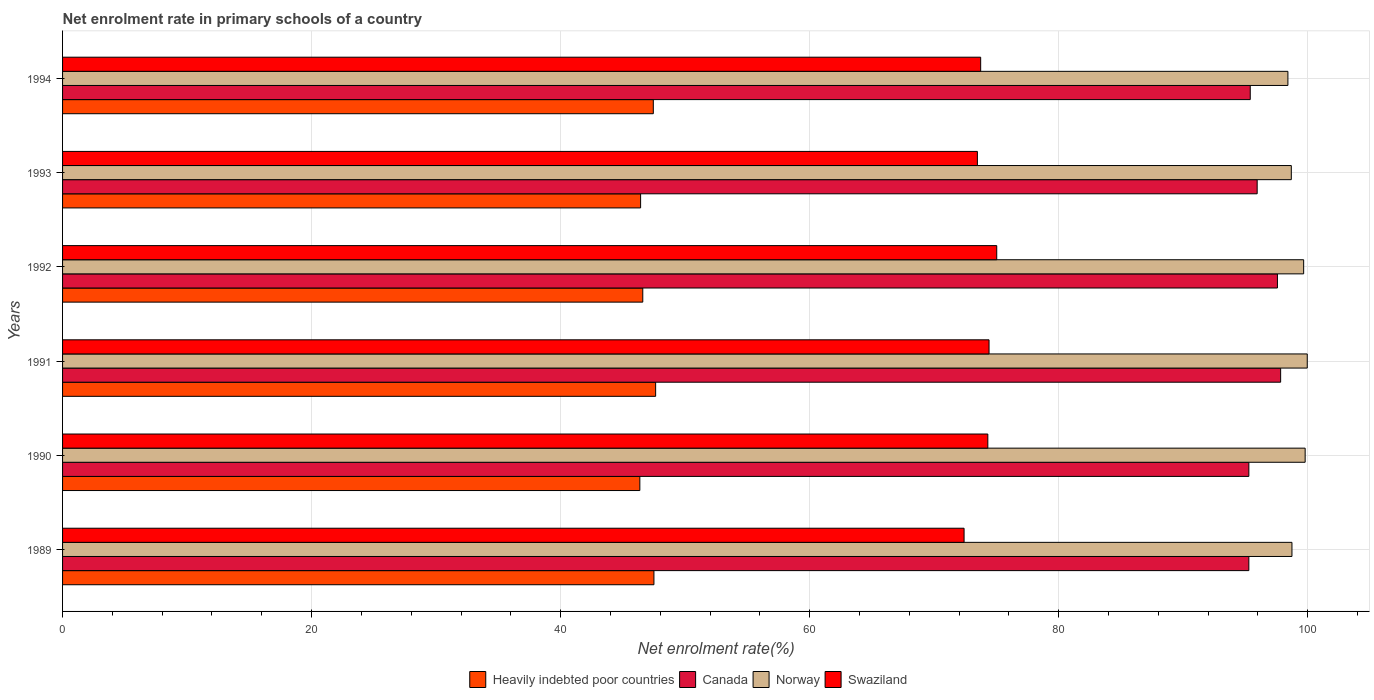How many bars are there on the 2nd tick from the bottom?
Your response must be concise. 4. What is the label of the 6th group of bars from the top?
Your answer should be very brief. 1989. What is the net enrolment rate in primary schools in Canada in 1992?
Provide a short and direct response. 97.57. Across all years, what is the maximum net enrolment rate in primary schools in Norway?
Offer a terse response. 99.97. Across all years, what is the minimum net enrolment rate in primary schools in Norway?
Offer a terse response. 98.41. What is the total net enrolment rate in primary schools in Swaziland in the graph?
Make the answer very short. 443.36. What is the difference between the net enrolment rate in primary schools in Canada in 1989 and that in 1991?
Ensure brevity in your answer.  -2.55. What is the difference between the net enrolment rate in primary schools in Canada in 1990 and the net enrolment rate in primary schools in Norway in 1989?
Make the answer very short. -3.46. What is the average net enrolment rate in primary schools in Canada per year?
Provide a short and direct response. 96.21. In the year 1990, what is the difference between the net enrolment rate in primary schools in Norway and net enrolment rate in primary schools in Canada?
Your response must be concise. 4.52. What is the ratio of the net enrolment rate in primary schools in Norway in 1989 to that in 1994?
Your answer should be very brief. 1. Is the difference between the net enrolment rate in primary schools in Norway in 1989 and 1992 greater than the difference between the net enrolment rate in primary schools in Canada in 1989 and 1992?
Provide a succinct answer. Yes. What is the difference between the highest and the second highest net enrolment rate in primary schools in Heavily indebted poor countries?
Offer a terse response. 0.14. What is the difference between the highest and the lowest net enrolment rate in primary schools in Heavily indebted poor countries?
Offer a very short reply. 1.27. In how many years, is the net enrolment rate in primary schools in Norway greater than the average net enrolment rate in primary schools in Norway taken over all years?
Provide a short and direct response. 3. What does the 4th bar from the top in 1992 represents?
Ensure brevity in your answer.  Heavily indebted poor countries. How many bars are there?
Give a very brief answer. 24. Are all the bars in the graph horizontal?
Provide a succinct answer. Yes. What is the difference between two consecutive major ticks on the X-axis?
Your response must be concise. 20. Are the values on the major ticks of X-axis written in scientific E-notation?
Offer a very short reply. No. Does the graph contain any zero values?
Your response must be concise. No. Where does the legend appear in the graph?
Provide a succinct answer. Bottom center. How many legend labels are there?
Your response must be concise. 4. What is the title of the graph?
Ensure brevity in your answer.  Net enrolment rate in primary schools of a country. What is the label or title of the X-axis?
Give a very brief answer. Net enrolment rate(%). What is the Net enrolment rate(%) in Heavily indebted poor countries in 1989?
Provide a short and direct response. 47.5. What is the Net enrolment rate(%) of Canada in 1989?
Provide a succinct answer. 95.27. What is the Net enrolment rate(%) of Norway in 1989?
Make the answer very short. 98.74. What is the Net enrolment rate(%) of Swaziland in 1989?
Give a very brief answer. 72.4. What is the Net enrolment rate(%) in Heavily indebted poor countries in 1990?
Make the answer very short. 46.36. What is the Net enrolment rate(%) in Canada in 1990?
Your response must be concise. 95.28. What is the Net enrolment rate(%) of Norway in 1990?
Give a very brief answer. 99.8. What is the Net enrolment rate(%) of Swaziland in 1990?
Provide a succinct answer. 74.31. What is the Net enrolment rate(%) in Heavily indebted poor countries in 1991?
Provide a short and direct response. 47.63. What is the Net enrolment rate(%) in Canada in 1991?
Keep it short and to the point. 97.83. What is the Net enrolment rate(%) of Norway in 1991?
Make the answer very short. 99.97. What is the Net enrolment rate(%) in Swaziland in 1991?
Your answer should be compact. 74.41. What is the Net enrolment rate(%) of Heavily indebted poor countries in 1992?
Offer a terse response. 46.6. What is the Net enrolment rate(%) in Canada in 1992?
Your answer should be very brief. 97.57. What is the Net enrolment rate(%) of Norway in 1992?
Give a very brief answer. 99.68. What is the Net enrolment rate(%) of Swaziland in 1992?
Keep it short and to the point. 75.03. What is the Net enrolment rate(%) in Heavily indebted poor countries in 1993?
Your response must be concise. 46.43. What is the Net enrolment rate(%) of Canada in 1993?
Offer a terse response. 95.94. What is the Net enrolment rate(%) of Norway in 1993?
Your answer should be compact. 98.69. What is the Net enrolment rate(%) in Swaziland in 1993?
Ensure brevity in your answer.  73.47. What is the Net enrolment rate(%) of Heavily indebted poor countries in 1994?
Ensure brevity in your answer.  47.45. What is the Net enrolment rate(%) of Canada in 1994?
Your answer should be compact. 95.39. What is the Net enrolment rate(%) of Norway in 1994?
Provide a short and direct response. 98.41. What is the Net enrolment rate(%) of Swaziland in 1994?
Ensure brevity in your answer.  73.74. Across all years, what is the maximum Net enrolment rate(%) of Heavily indebted poor countries?
Give a very brief answer. 47.63. Across all years, what is the maximum Net enrolment rate(%) of Canada?
Your answer should be compact. 97.83. Across all years, what is the maximum Net enrolment rate(%) of Norway?
Your answer should be very brief. 99.97. Across all years, what is the maximum Net enrolment rate(%) of Swaziland?
Provide a short and direct response. 75.03. Across all years, what is the minimum Net enrolment rate(%) of Heavily indebted poor countries?
Provide a short and direct response. 46.36. Across all years, what is the minimum Net enrolment rate(%) in Canada?
Offer a very short reply. 95.27. Across all years, what is the minimum Net enrolment rate(%) of Norway?
Offer a terse response. 98.41. Across all years, what is the minimum Net enrolment rate(%) in Swaziland?
Offer a terse response. 72.4. What is the total Net enrolment rate(%) in Heavily indebted poor countries in the graph?
Your response must be concise. 281.96. What is the total Net enrolment rate(%) in Canada in the graph?
Provide a succinct answer. 577.28. What is the total Net enrolment rate(%) of Norway in the graph?
Keep it short and to the point. 595.28. What is the total Net enrolment rate(%) in Swaziland in the graph?
Offer a very short reply. 443.36. What is the difference between the Net enrolment rate(%) of Heavily indebted poor countries in 1989 and that in 1990?
Give a very brief answer. 1.13. What is the difference between the Net enrolment rate(%) in Canada in 1989 and that in 1990?
Offer a very short reply. -0. What is the difference between the Net enrolment rate(%) of Norway in 1989 and that in 1990?
Your answer should be very brief. -1.06. What is the difference between the Net enrolment rate(%) in Swaziland in 1989 and that in 1990?
Your answer should be compact. -1.91. What is the difference between the Net enrolment rate(%) of Heavily indebted poor countries in 1989 and that in 1991?
Offer a very short reply. -0.14. What is the difference between the Net enrolment rate(%) in Canada in 1989 and that in 1991?
Offer a very short reply. -2.55. What is the difference between the Net enrolment rate(%) in Norway in 1989 and that in 1991?
Your response must be concise. -1.23. What is the difference between the Net enrolment rate(%) of Swaziland in 1989 and that in 1991?
Give a very brief answer. -2.01. What is the difference between the Net enrolment rate(%) of Heavily indebted poor countries in 1989 and that in 1992?
Keep it short and to the point. 0.9. What is the difference between the Net enrolment rate(%) in Canada in 1989 and that in 1992?
Offer a terse response. -2.3. What is the difference between the Net enrolment rate(%) in Norway in 1989 and that in 1992?
Offer a terse response. -0.94. What is the difference between the Net enrolment rate(%) of Swaziland in 1989 and that in 1992?
Your response must be concise. -2.62. What is the difference between the Net enrolment rate(%) of Heavily indebted poor countries in 1989 and that in 1993?
Provide a short and direct response. 1.07. What is the difference between the Net enrolment rate(%) in Canada in 1989 and that in 1993?
Provide a succinct answer. -0.67. What is the difference between the Net enrolment rate(%) of Norway in 1989 and that in 1993?
Offer a very short reply. 0.05. What is the difference between the Net enrolment rate(%) in Swaziland in 1989 and that in 1993?
Provide a short and direct response. -1.07. What is the difference between the Net enrolment rate(%) in Heavily indebted poor countries in 1989 and that in 1994?
Provide a succinct answer. 0.05. What is the difference between the Net enrolment rate(%) of Canada in 1989 and that in 1994?
Your response must be concise. -0.11. What is the difference between the Net enrolment rate(%) of Norway in 1989 and that in 1994?
Give a very brief answer. 0.33. What is the difference between the Net enrolment rate(%) of Swaziland in 1989 and that in 1994?
Your response must be concise. -1.33. What is the difference between the Net enrolment rate(%) of Heavily indebted poor countries in 1990 and that in 1991?
Give a very brief answer. -1.27. What is the difference between the Net enrolment rate(%) in Canada in 1990 and that in 1991?
Offer a terse response. -2.55. What is the difference between the Net enrolment rate(%) of Norway in 1990 and that in 1991?
Make the answer very short. -0.17. What is the difference between the Net enrolment rate(%) of Swaziland in 1990 and that in 1991?
Offer a terse response. -0.1. What is the difference between the Net enrolment rate(%) in Heavily indebted poor countries in 1990 and that in 1992?
Offer a terse response. -0.24. What is the difference between the Net enrolment rate(%) in Canada in 1990 and that in 1992?
Ensure brevity in your answer.  -2.3. What is the difference between the Net enrolment rate(%) in Norway in 1990 and that in 1992?
Keep it short and to the point. 0.12. What is the difference between the Net enrolment rate(%) in Swaziland in 1990 and that in 1992?
Keep it short and to the point. -0.72. What is the difference between the Net enrolment rate(%) in Heavily indebted poor countries in 1990 and that in 1993?
Your answer should be very brief. -0.06. What is the difference between the Net enrolment rate(%) in Canada in 1990 and that in 1993?
Your answer should be compact. -0.67. What is the difference between the Net enrolment rate(%) of Norway in 1990 and that in 1993?
Give a very brief answer. 1.11. What is the difference between the Net enrolment rate(%) in Swaziland in 1990 and that in 1993?
Provide a short and direct response. 0.84. What is the difference between the Net enrolment rate(%) of Heavily indebted poor countries in 1990 and that in 1994?
Provide a short and direct response. -1.08. What is the difference between the Net enrolment rate(%) in Canada in 1990 and that in 1994?
Your answer should be very brief. -0.11. What is the difference between the Net enrolment rate(%) in Norway in 1990 and that in 1994?
Offer a terse response. 1.39. What is the difference between the Net enrolment rate(%) of Swaziland in 1990 and that in 1994?
Offer a terse response. 0.57. What is the difference between the Net enrolment rate(%) of Heavily indebted poor countries in 1991 and that in 1992?
Provide a short and direct response. 1.03. What is the difference between the Net enrolment rate(%) in Canada in 1991 and that in 1992?
Your answer should be very brief. 0.26. What is the difference between the Net enrolment rate(%) of Norway in 1991 and that in 1992?
Give a very brief answer. 0.29. What is the difference between the Net enrolment rate(%) in Swaziland in 1991 and that in 1992?
Ensure brevity in your answer.  -0.62. What is the difference between the Net enrolment rate(%) of Heavily indebted poor countries in 1991 and that in 1993?
Your response must be concise. 1.21. What is the difference between the Net enrolment rate(%) of Canada in 1991 and that in 1993?
Provide a short and direct response. 1.88. What is the difference between the Net enrolment rate(%) in Norway in 1991 and that in 1993?
Offer a very short reply. 1.28. What is the difference between the Net enrolment rate(%) of Swaziland in 1991 and that in 1993?
Make the answer very short. 0.94. What is the difference between the Net enrolment rate(%) of Heavily indebted poor countries in 1991 and that in 1994?
Offer a terse response. 0.19. What is the difference between the Net enrolment rate(%) of Canada in 1991 and that in 1994?
Offer a very short reply. 2.44. What is the difference between the Net enrolment rate(%) in Norway in 1991 and that in 1994?
Offer a very short reply. 1.55. What is the difference between the Net enrolment rate(%) in Swaziland in 1991 and that in 1994?
Offer a very short reply. 0.67. What is the difference between the Net enrolment rate(%) in Heavily indebted poor countries in 1992 and that in 1993?
Your answer should be very brief. 0.17. What is the difference between the Net enrolment rate(%) of Canada in 1992 and that in 1993?
Your answer should be very brief. 1.63. What is the difference between the Net enrolment rate(%) in Norway in 1992 and that in 1993?
Keep it short and to the point. 0.99. What is the difference between the Net enrolment rate(%) of Swaziland in 1992 and that in 1993?
Ensure brevity in your answer.  1.55. What is the difference between the Net enrolment rate(%) of Heavily indebted poor countries in 1992 and that in 1994?
Ensure brevity in your answer.  -0.85. What is the difference between the Net enrolment rate(%) in Canada in 1992 and that in 1994?
Make the answer very short. 2.18. What is the difference between the Net enrolment rate(%) in Norway in 1992 and that in 1994?
Your answer should be very brief. 1.26. What is the difference between the Net enrolment rate(%) of Swaziland in 1992 and that in 1994?
Your answer should be compact. 1.29. What is the difference between the Net enrolment rate(%) in Heavily indebted poor countries in 1993 and that in 1994?
Make the answer very short. -1.02. What is the difference between the Net enrolment rate(%) of Canada in 1993 and that in 1994?
Provide a short and direct response. 0.56. What is the difference between the Net enrolment rate(%) in Norway in 1993 and that in 1994?
Offer a terse response. 0.27. What is the difference between the Net enrolment rate(%) of Swaziland in 1993 and that in 1994?
Offer a very short reply. -0.26. What is the difference between the Net enrolment rate(%) in Heavily indebted poor countries in 1989 and the Net enrolment rate(%) in Canada in 1990?
Ensure brevity in your answer.  -47.78. What is the difference between the Net enrolment rate(%) of Heavily indebted poor countries in 1989 and the Net enrolment rate(%) of Norway in 1990?
Your answer should be very brief. -52.3. What is the difference between the Net enrolment rate(%) in Heavily indebted poor countries in 1989 and the Net enrolment rate(%) in Swaziland in 1990?
Offer a very short reply. -26.82. What is the difference between the Net enrolment rate(%) in Canada in 1989 and the Net enrolment rate(%) in Norway in 1990?
Provide a succinct answer. -4.52. What is the difference between the Net enrolment rate(%) of Canada in 1989 and the Net enrolment rate(%) of Swaziland in 1990?
Your response must be concise. 20.96. What is the difference between the Net enrolment rate(%) of Norway in 1989 and the Net enrolment rate(%) of Swaziland in 1990?
Keep it short and to the point. 24.43. What is the difference between the Net enrolment rate(%) in Heavily indebted poor countries in 1989 and the Net enrolment rate(%) in Canada in 1991?
Make the answer very short. -50.33. What is the difference between the Net enrolment rate(%) of Heavily indebted poor countries in 1989 and the Net enrolment rate(%) of Norway in 1991?
Your response must be concise. -52.47. What is the difference between the Net enrolment rate(%) in Heavily indebted poor countries in 1989 and the Net enrolment rate(%) in Swaziland in 1991?
Offer a terse response. -26.91. What is the difference between the Net enrolment rate(%) in Canada in 1989 and the Net enrolment rate(%) in Norway in 1991?
Provide a short and direct response. -4.69. What is the difference between the Net enrolment rate(%) of Canada in 1989 and the Net enrolment rate(%) of Swaziland in 1991?
Ensure brevity in your answer.  20.87. What is the difference between the Net enrolment rate(%) in Norway in 1989 and the Net enrolment rate(%) in Swaziland in 1991?
Make the answer very short. 24.33. What is the difference between the Net enrolment rate(%) in Heavily indebted poor countries in 1989 and the Net enrolment rate(%) in Canada in 1992?
Make the answer very short. -50.08. What is the difference between the Net enrolment rate(%) in Heavily indebted poor countries in 1989 and the Net enrolment rate(%) in Norway in 1992?
Ensure brevity in your answer.  -52.18. What is the difference between the Net enrolment rate(%) in Heavily indebted poor countries in 1989 and the Net enrolment rate(%) in Swaziland in 1992?
Offer a terse response. -27.53. What is the difference between the Net enrolment rate(%) of Canada in 1989 and the Net enrolment rate(%) of Norway in 1992?
Provide a short and direct response. -4.4. What is the difference between the Net enrolment rate(%) in Canada in 1989 and the Net enrolment rate(%) in Swaziland in 1992?
Keep it short and to the point. 20.25. What is the difference between the Net enrolment rate(%) of Norway in 1989 and the Net enrolment rate(%) of Swaziland in 1992?
Keep it short and to the point. 23.71. What is the difference between the Net enrolment rate(%) of Heavily indebted poor countries in 1989 and the Net enrolment rate(%) of Canada in 1993?
Give a very brief answer. -48.45. What is the difference between the Net enrolment rate(%) in Heavily indebted poor countries in 1989 and the Net enrolment rate(%) in Norway in 1993?
Your answer should be compact. -51.19. What is the difference between the Net enrolment rate(%) of Heavily indebted poor countries in 1989 and the Net enrolment rate(%) of Swaziland in 1993?
Your response must be concise. -25.98. What is the difference between the Net enrolment rate(%) of Canada in 1989 and the Net enrolment rate(%) of Norway in 1993?
Keep it short and to the point. -3.41. What is the difference between the Net enrolment rate(%) of Canada in 1989 and the Net enrolment rate(%) of Swaziland in 1993?
Keep it short and to the point. 21.8. What is the difference between the Net enrolment rate(%) of Norway in 1989 and the Net enrolment rate(%) of Swaziland in 1993?
Offer a terse response. 25.26. What is the difference between the Net enrolment rate(%) in Heavily indebted poor countries in 1989 and the Net enrolment rate(%) in Canada in 1994?
Your answer should be compact. -47.89. What is the difference between the Net enrolment rate(%) in Heavily indebted poor countries in 1989 and the Net enrolment rate(%) in Norway in 1994?
Make the answer very short. -50.92. What is the difference between the Net enrolment rate(%) of Heavily indebted poor countries in 1989 and the Net enrolment rate(%) of Swaziland in 1994?
Your answer should be compact. -26.24. What is the difference between the Net enrolment rate(%) in Canada in 1989 and the Net enrolment rate(%) in Norway in 1994?
Keep it short and to the point. -3.14. What is the difference between the Net enrolment rate(%) of Canada in 1989 and the Net enrolment rate(%) of Swaziland in 1994?
Provide a succinct answer. 21.54. What is the difference between the Net enrolment rate(%) of Norway in 1989 and the Net enrolment rate(%) of Swaziland in 1994?
Provide a succinct answer. 25. What is the difference between the Net enrolment rate(%) in Heavily indebted poor countries in 1990 and the Net enrolment rate(%) in Canada in 1991?
Make the answer very short. -51.47. What is the difference between the Net enrolment rate(%) of Heavily indebted poor countries in 1990 and the Net enrolment rate(%) of Norway in 1991?
Provide a short and direct response. -53.6. What is the difference between the Net enrolment rate(%) of Heavily indebted poor countries in 1990 and the Net enrolment rate(%) of Swaziland in 1991?
Make the answer very short. -28.05. What is the difference between the Net enrolment rate(%) in Canada in 1990 and the Net enrolment rate(%) in Norway in 1991?
Give a very brief answer. -4.69. What is the difference between the Net enrolment rate(%) of Canada in 1990 and the Net enrolment rate(%) of Swaziland in 1991?
Your answer should be compact. 20.87. What is the difference between the Net enrolment rate(%) in Norway in 1990 and the Net enrolment rate(%) in Swaziland in 1991?
Make the answer very short. 25.39. What is the difference between the Net enrolment rate(%) in Heavily indebted poor countries in 1990 and the Net enrolment rate(%) in Canada in 1992?
Make the answer very short. -51.21. What is the difference between the Net enrolment rate(%) in Heavily indebted poor countries in 1990 and the Net enrolment rate(%) in Norway in 1992?
Offer a terse response. -53.31. What is the difference between the Net enrolment rate(%) of Heavily indebted poor countries in 1990 and the Net enrolment rate(%) of Swaziland in 1992?
Your answer should be very brief. -28.66. What is the difference between the Net enrolment rate(%) in Canada in 1990 and the Net enrolment rate(%) in Norway in 1992?
Give a very brief answer. -4.4. What is the difference between the Net enrolment rate(%) of Canada in 1990 and the Net enrolment rate(%) of Swaziland in 1992?
Your answer should be compact. 20.25. What is the difference between the Net enrolment rate(%) of Norway in 1990 and the Net enrolment rate(%) of Swaziland in 1992?
Provide a short and direct response. 24.77. What is the difference between the Net enrolment rate(%) in Heavily indebted poor countries in 1990 and the Net enrolment rate(%) in Canada in 1993?
Keep it short and to the point. -49.58. What is the difference between the Net enrolment rate(%) in Heavily indebted poor countries in 1990 and the Net enrolment rate(%) in Norway in 1993?
Keep it short and to the point. -52.32. What is the difference between the Net enrolment rate(%) of Heavily indebted poor countries in 1990 and the Net enrolment rate(%) of Swaziland in 1993?
Offer a very short reply. -27.11. What is the difference between the Net enrolment rate(%) of Canada in 1990 and the Net enrolment rate(%) of Norway in 1993?
Give a very brief answer. -3.41. What is the difference between the Net enrolment rate(%) in Canada in 1990 and the Net enrolment rate(%) in Swaziland in 1993?
Your answer should be compact. 21.8. What is the difference between the Net enrolment rate(%) in Norway in 1990 and the Net enrolment rate(%) in Swaziland in 1993?
Offer a very short reply. 26.32. What is the difference between the Net enrolment rate(%) in Heavily indebted poor countries in 1990 and the Net enrolment rate(%) in Canada in 1994?
Provide a succinct answer. -49.03. What is the difference between the Net enrolment rate(%) of Heavily indebted poor countries in 1990 and the Net enrolment rate(%) of Norway in 1994?
Offer a terse response. -52.05. What is the difference between the Net enrolment rate(%) of Heavily indebted poor countries in 1990 and the Net enrolment rate(%) of Swaziland in 1994?
Keep it short and to the point. -27.37. What is the difference between the Net enrolment rate(%) of Canada in 1990 and the Net enrolment rate(%) of Norway in 1994?
Your answer should be compact. -3.14. What is the difference between the Net enrolment rate(%) of Canada in 1990 and the Net enrolment rate(%) of Swaziland in 1994?
Offer a terse response. 21.54. What is the difference between the Net enrolment rate(%) in Norway in 1990 and the Net enrolment rate(%) in Swaziland in 1994?
Your answer should be compact. 26.06. What is the difference between the Net enrolment rate(%) of Heavily indebted poor countries in 1991 and the Net enrolment rate(%) of Canada in 1992?
Your answer should be very brief. -49.94. What is the difference between the Net enrolment rate(%) of Heavily indebted poor countries in 1991 and the Net enrolment rate(%) of Norway in 1992?
Offer a terse response. -52.04. What is the difference between the Net enrolment rate(%) in Heavily indebted poor countries in 1991 and the Net enrolment rate(%) in Swaziland in 1992?
Offer a very short reply. -27.4. What is the difference between the Net enrolment rate(%) in Canada in 1991 and the Net enrolment rate(%) in Norway in 1992?
Your response must be concise. -1.85. What is the difference between the Net enrolment rate(%) of Canada in 1991 and the Net enrolment rate(%) of Swaziland in 1992?
Your response must be concise. 22.8. What is the difference between the Net enrolment rate(%) of Norway in 1991 and the Net enrolment rate(%) of Swaziland in 1992?
Keep it short and to the point. 24.94. What is the difference between the Net enrolment rate(%) of Heavily indebted poor countries in 1991 and the Net enrolment rate(%) of Canada in 1993?
Offer a terse response. -48.31. What is the difference between the Net enrolment rate(%) in Heavily indebted poor countries in 1991 and the Net enrolment rate(%) in Norway in 1993?
Ensure brevity in your answer.  -51.05. What is the difference between the Net enrolment rate(%) of Heavily indebted poor countries in 1991 and the Net enrolment rate(%) of Swaziland in 1993?
Offer a very short reply. -25.84. What is the difference between the Net enrolment rate(%) of Canada in 1991 and the Net enrolment rate(%) of Norway in 1993?
Make the answer very short. -0.86. What is the difference between the Net enrolment rate(%) of Canada in 1991 and the Net enrolment rate(%) of Swaziland in 1993?
Make the answer very short. 24.35. What is the difference between the Net enrolment rate(%) of Norway in 1991 and the Net enrolment rate(%) of Swaziland in 1993?
Offer a very short reply. 26.49. What is the difference between the Net enrolment rate(%) in Heavily indebted poor countries in 1991 and the Net enrolment rate(%) in Canada in 1994?
Provide a succinct answer. -47.76. What is the difference between the Net enrolment rate(%) in Heavily indebted poor countries in 1991 and the Net enrolment rate(%) in Norway in 1994?
Keep it short and to the point. -50.78. What is the difference between the Net enrolment rate(%) in Heavily indebted poor countries in 1991 and the Net enrolment rate(%) in Swaziland in 1994?
Give a very brief answer. -26.11. What is the difference between the Net enrolment rate(%) in Canada in 1991 and the Net enrolment rate(%) in Norway in 1994?
Your answer should be compact. -0.58. What is the difference between the Net enrolment rate(%) of Canada in 1991 and the Net enrolment rate(%) of Swaziland in 1994?
Keep it short and to the point. 24.09. What is the difference between the Net enrolment rate(%) of Norway in 1991 and the Net enrolment rate(%) of Swaziland in 1994?
Provide a succinct answer. 26.23. What is the difference between the Net enrolment rate(%) of Heavily indebted poor countries in 1992 and the Net enrolment rate(%) of Canada in 1993?
Provide a succinct answer. -49.34. What is the difference between the Net enrolment rate(%) of Heavily indebted poor countries in 1992 and the Net enrolment rate(%) of Norway in 1993?
Provide a succinct answer. -52.09. What is the difference between the Net enrolment rate(%) of Heavily indebted poor countries in 1992 and the Net enrolment rate(%) of Swaziland in 1993?
Offer a terse response. -26.87. What is the difference between the Net enrolment rate(%) of Canada in 1992 and the Net enrolment rate(%) of Norway in 1993?
Your response must be concise. -1.11. What is the difference between the Net enrolment rate(%) in Canada in 1992 and the Net enrolment rate(%) in Swaziland in 1993?
Your answer should be very brief. 24.1. What is the difference between the Net enrolment rate(%) in Norway in 1992 and the Net enrolment rate(%) in Swaziland in 1993?
Offer a very short reply. 26.2. What is the difference between the Net enrolment rate(%) in Heavily indebted poor countries in 1992 and the Net enrolment rate(%) in Canada in 1994?
Provide a short and direct response. -48.79. What is the difference between the Net enrolment rate(%) of Heavily indebted poor countries in 1992 and the Net enrolment rate(%) of Norway in 1994?
Give a very brief answer. -51.81. What is the difference between the Net enrolment rate(%) in Heavily indebted poor countries in 1992 and the Net enrolment rate(%) in Swaziland in 1994?
Ensure brevity in your answer.  -27.14. What is the difference between the Net enrolment rate(%) of Canada in 1992 and the Net enrolment rate(%) of Norway in 1994?
Provide a succinct answer. -0.84. What is the difference between the Net enrolment rate(%) in Canada in 1992 and the Net enrolment rate(%) in Swaziland in 1994?
Your answer should be compact. 23.83. What is the difference between the Net enrolment rate(%) of Norway in 1992 and the Net enrolment rate(%) of Swaziland in 1994?
Offer a very short reply. 25.94. What is the difference between the Net enrolment rate(%) of Heavily indebted poor countries in 1993 and the Net enrolment rate(%) of Canada in 1994?
Your answer should be compact. -48.96. What is the difference between the Net enrolment rate(%) in Heavily indebted poor countries in 1993 and the Net enrolment rate(%) in Norway in 1994?
Your answer should be compact. -51.99. What is the difference between the Net enrolment rate(%) in Heavily indebted poor countries in 1993 and the Net enrolment rate(%) in Swaziland in 1994?
Your answer should be very brief. -27.31. What is the difference between the Net enrolment rate(%) in Canada in 1993 and the Net enrolment rate(%) in Norway in 1994?
Your answer should be very brief. -2.47. What is the difference between the Net enrolment rate(%) of Canada in 1993 and the Net enrolment rate(%) of Swaziland in 1994?
Give a very brief answer. 22.21. What is the difference between the Net enrolment rate(%) in Norway in 1993 and the Net enrolment rate(%) in Swaziland in 1994?
Your answer should be very brief. 24.95. What is the average Net enrolment rate(%) in Heavily indebted poor countries per year?
Provide a short and direct response. 46.99. What is the average Net enrolment rate(%) of Canada per year?
Your response must be concise. 96.21. What is the average Net enrolment rate(%) of Norway per year?
Offer a terse response. 99.21. What is the average Net enrolment rate(%) of Swaziland per year?
Your answer should be compact. 73.89. In the year 1989, what is the difference between the Net enrolment rate(%) of Heavily indebted poor countries and Net enrolment rate(%) of Canada?
Your answer should be very brief. -47.78. In the year 1989, what is the difference between the Net enrolment rate(%) in Heavily indebted poor countries and Net enrolment rate(%) in Norway?
Offer a terse response. -51.24. In the year 1989, what is the difference between the Net enrolment rate(%) in Heavily indebted poor countries and Net enrolment rate(%) in Swaziland?
Give a very brief answer. -24.91. In the year 1989, what is the difference between the Net enrolment rate(%) in Canada and Net enrolment rate(%) in Norway?
Offer a very short reply. -3.46. In the year 1989, what is the difference between the Net enrolment rate(%) in Canada and Net enrolment rate(%) in Swaziland?
Your answer should be compact. 22.87. In the year 1989, what is the difference between the Net enrolment rate(%) of Norway and Net enrolment rate(%) of Swaziland?
Give a very brief answer. 26.33. In the year 1990, what is the difference between the Net enrolment rate(%) in Heavily indebted poor countries and Net enrolment rate(%) in Canada?
Provide a short and direct response. -48.91. In the year 1990, what is the difference between the Net enrolment rate(%) of Heavily indebted poor countries and Net enrolment rate(%) of Norway?
Your answer should be compact. -53.44. In the year 1990, what is the difference between the Net enrolment rate(%) of Heavily indebted poor countries and Net enrolment rate(%) of Swaziland?
Keep it short and to the point. -27.95. In the year 1990, what is the difference between the Net enrolment rate(%) in Canada and Net enrolment rate(%) in Norway?
Ensure brevity in your answer.  -4.52. In the year 1990, what is the difference between the Net enrolment rate(%) in Canada and Net enrolment rate(%) in Swaziland?
Offer a terse response. 20.96. In the year 1990, what is the difference between the Net enrolment rate(%) in Norway and Net enrolment rate(%) in Swaziland?
Offer a terse response. 25.49. In the year 1991, what is the difference between the Net enrolment rate(%) of Heavily indebted poor countries and Net enrolment rate(%) of Canada?
Make the answer very short. -50.2. In the year 1991, what is the difference between the Net enrolment rate(%) in Heavily indebted poor countries and Net enrolment rate(%) in Norway?
Offer a terse response. -52.33. In the year 1991, what is the difference between the Net enrolment rate(%) in Heavily indebted poor countries and Net enrolment rate(%) in Swaziland?
Your answer should be very brief. -26.78. In the year 1991, what is the difference between the Net enrolment rate(%) of Canada and Net enrolment rate(%) of Norway?
Give a very brief answer. -2.14. In the year 1991, what is the difference between the Net enrolment rate(%) in Canada and Net enrolment rate(%) in Swaziland?
Your answer should be very brief. 23.42. In the year 1991, what is the difference between the Net enrolment rate(%) in Norway and Net enrolment rate(%) in Swaziland?
Your answer should be compact. 25.56. In the year 1992, what is the difference between the Net enrolment rate(%) in Heavily indebted poor countries and Net enrolment rate(%) in Canada?
Give a very brief answer. -50.97. In the year 1992, what is the difference between the Net enrolment rate(%) of Heavily indebted poor countries and Net enrolment rate(%) of Norway?
Keep it short and to the point. -53.08. In the year 1992, what is the difference between the Net enrolment rate(%) of Heavily indebted poor countries and Net enrolment rate(%) of Swaziland?
Your response must be concise. -28.43. In the year 1992, what is the difference between the Net enrolment rate(%) of Canada and Net enrolment rate(%) of Norway?
Give a very brief answer. -2.11. In the year 1992, what is the difference between the Net enrolment rate(%) in Canada and Net enrolment rate(%) in Swaziland?
Ensure brevity in your answer.  22.54. In the year 1992, what is the difference between the Net enrolment rate(%) of Norway and Net enrolment rate(%) of Swaziland?
Provide a succinct answer. 24.65. In the year 1993, what is the difference between the Net enrolment rate(%) of Heavily indebted poor countries and Net enrolment rate(%) of Canada?
Provide a succinct answer. -49.52. In the year 1993, what is the difference between the Net enrolment rate(%) in Heavily indebted poor countries and Net enrolment rate(%) in Norway?
Offer a very short reply. -52.26. In the year 1993, what is the difference between the Net enrolment rate(%) of Heavily indebted poor countries and Net enrolment rate(%) of Swaziland?
Provide a short and direct response. -27.05. In the year 1993, what is the difference between the Net enrolment rate(%) of Canada and Net enrolment rate(%) of Norway?
Provide a succinct answer. -2.74. In the year 1993, what is the difference between the Net enrolment rate(%) in Canada and Net enrolment rate(%) in Swaziland?
Make the answer very short. 22.47. In the year 1993, what is the difference between the Net enrolment rate(%) in Norway and Net enrolment rate(%) in Swaziland?
Your answer should be compact. 25.21. In the year 1994, what is the difference between the Net enrolment rate(%) in Heavily indebted poor countries and Net enrolment rate(%) in Canada?
Your response must be concise. -47.94. In the year 1994, what is the difference between the Net enrolment rate(%) in Heavily indebted poor countries and Net enrolment rate(%) in Norway?
Give a very brief answer. -50.97. In the year 1994, what is the difference between the Net enrolment rate(%) in Heavily indebted poor countries and Net enrolment rate(%) in Swaziland?
Give a very brief answer. -26.29. In the year 1994, what is the difference between the Net enrolment rate(%) of Canada and Net enrolment rate(%) of Norway?
Offer a terse response. -3.02. In the year 1994, what is the difference between the Net enrolment rate(%) of Canada and Net enrolment rate(%) of Swaziland?
Your answer should be compact. 21.65. In the year 1994, what is the difference between the Net enrolment rate(%) in Norway and Net enrolment rate(%) in Swaziland?
Offer a very short reply. 24.68. What is the ratio of the Net enrolment rate(%) in Heavily indebted poor countries in 1989 to that in 1990?
Keep it short and to the point. 1.02. What is the ratio of the Net enrolment rate(%) of Canada in 1989 to that in 1990?
Offer a terse response. 1. What is the ratio of the Net enrolment rate(%) of Swaziland in 1989 to that in 1990?
Provide a short and direct response. 0.97. What is the ratio of the Net enrolment rate(%) of Canada in 1989 to that in 1991?
Give a very brief answer. 0.97. What is the ratio of the Net enrolment rate(%) of Swaziland in 1989 to that in 1991?
Provide a succinct answer. 0.97. What is the ratio of the Net enrolment rate(%) of Heavily indebted poor countries in 1989 to that in 1992?
Provide a short and direct response. 1.02. What is the ratio of the Net enrolment rate(%) in Canada in 1989 to that in 1992?
Offer a very short reply. 0.98. What is the ratio of the Net enrolment rate(%) in Norway in 1989 to that in 1992?
Your answer should be compact. 0.99. What is the ratio of the Net enrolment rate(%) of Swaziland in 1989 to that in 1992?
Make the answer very short. 0.96. What is the ratio of the Net enrolment rate(%) of Norway in 1989 to that in 1993?
Keep it short and to the point. 1. What is the ratio of the Net enrolment rate(%) in Swaziland in 1989 to that in 1993?
Make the answer very short. 0.99. What is the ratio of the Net enrolment rate(%) of Heavily indebted poor countries in 1989 to that in 1994?
Your answer should be very brief. 1. What is the ratio of the Net enrolment rate(%) in Swaziland in 1989 to that in 1994?
Give a very brief answer. 0.98. What is the ratio of the Net enrolment rate(%) of Heavily indebted poor countries in 1990 to that in 1991?
Your answer should be compact. 0.97. What is the ratio of the Net enrolment rate(%) of Canada in 1990 to that in 1991?
Your answer should be very brief. 0.97. What is the ratio of the Net enrolment rate(%) of Swaziland in 1990 to that in 1991?
Provide a short and direct response. 1. What is the ratio of the Net enrolment rate(%) in Heavily indebted poor countries in 1990 to that in 1992?
Ensure brevity in your answer.  0.99. What is the ratio of the Net enrolment rate(%) in Canada in 1990 to that in 1992?
Ensure brevity in your answer.  0.98. What is the ratio of the Net enrolment rate(%) of Norway in 1990 to that in 1992?
Offer a very short reply. 1. What is the ratio of the Net enrolment rate(%) in Swaziland in 1990 to that in 1992?
Offer a very short reply. 0.99. What is the ratio of the Net enrolment rate(%) in Heavily indebted poor countries in 1990 to that in 1993?
Provide a succinct answer. 1. What is the ratio of the Net enrolment rate(%) of Canada in 1990 to that in 1993?
Offer a very short reply. 0.99. What is the ratio of the Net enrolment rate(%) in Norway in 1990 to that in 1993?
Make the answer very short. 1.01. What is the ratio of the Net enrolment rate(%) in Swaziland in 1990 to that in 1993?
Offer a very short reply. 1.01. What is the ratio of the Net enrolment rate(%) in Heavily indebted poor countries in 1990 to that in 1994?
Provide a succinct answer. 0.98. What is the ratio of the Net enrolment rate(%) in Norway in 1990 to that in 1994?
Give a very brief answer. 1.01. What is the ratio of the Net enrolment rate(%) of Heavily indebted poor countries in 1991 to that in 1992?
Your response must be concise. 1.02. What is the ratio of the Net enrolment rate(%) of Canada in 1991 to that in 1992?
Ensure brevity in your answer.  1. What is the ratio of the Net enrolment rate(%) of Norway in 1991 to that in 1992?
Offer a very short reply. 1. What is the ratio of the Net enrolment rate(%) in Swaziland in 1991 to that in 1992?
Ensure brevity in your answer.  0.99. What is the ratio of the Net enrolment rate(%) of Canada in 1991 to that in 1993?
Offer a terse response. 1.02. What is the ratio of the Net enrolment rate(%) in Norway in 1991 to that in 1993?
Your answer should be very brief. 1.01. What is the ratio of the Net enrolment rate(%) in Swaziland in 1991 to that in 1993?
Your answer should be compact. 1.01. What is the ratio of the Net enrolment rate(%) in Heavily indebted poor countries in 1991 to that in 1994?
Your answer should be very brief. 1. What is the ratio of the Net enrolment rate(%) in Canada in 1991 to that in 1994?
Keep it short and to the point. 1.03. What is the ratio of the Net enrolment rate(%) of Norway in 1991 to that in 1994?
Your answer should be compact. 1.02. What is the ratio of the Net enrolment rate(%) in Swaziland in 1991 to that in 1994?
Provide a short and direct response. 1.01. What is the ratio of the Net enrolment rate(%) in Swaziland in 1992 to that in 1993?
Make the answer very short. 1.02. What is the ratio of the Net enrolment rate(%) in Heavily indebted poor countries in 1992 to that in 1994?
Ensure brevity in your answer.  0.98. What is the ratio of the Net enrolment rate(%) of Canada in 1992 to that in 1994?
Give a very brief answer. 1.02. What is the ratio of the Net enrolment rate(%) of Norway in 1992 to that in 1994?
Provide a short and direct response. 1.01. What is the ratio of the Net enrolment rate(%) in Swaziland in 1992 to that in 1994?
Offer a terse response. 1.02. What is the ratio of the Net enrolment rate(%) of Heavily indebted poor countries in 1993 to that in 1994?
Your answer should be compact. 0.98. What is the ratio of the Net enrolment rate(%) of Norway in 1993 to that in 1994?
Provide a short and direct response. 1. What is the ratio of the Net enrolment rate(%) in Swaziland in 1993 to that in 1994?
Make the answer very short. 1. What is the difference between the highest and the second highest Net enrolment rate(%) of Heavily indebted poor countries?
Offer a terse response. 0.14. What is the difference between the highest and the second highest Net enrolment rate(%) of Canada?
Provide a succinct answer. 0.26. What is the difference between the highest and the second highest Net enrolment rate(%) of Norway?
Provide a succinct answer. 0.17. What is the difference between the highest and the second highest Net enrolment rate(%) of Swaziland?
Offer a terse response. 0.62. What is the difference between the highest and the lowest Net enrolment rate(%) of Heavily indebted poor countries?
Provide a succinct answer. 1.27. What is the difference between the highest and the lowest Net enrolment rate(%) of Canada?
Your response must be concise. 2.55. What is the difference between the highest and the lowest Net enrolment rate(%) in Norway?
Provide a short and direct response. 1.55. What is the difference between the highest and the lowest Net enrolment rate(%) of Swaziland?
Provide a succinct answer. 2.62. 